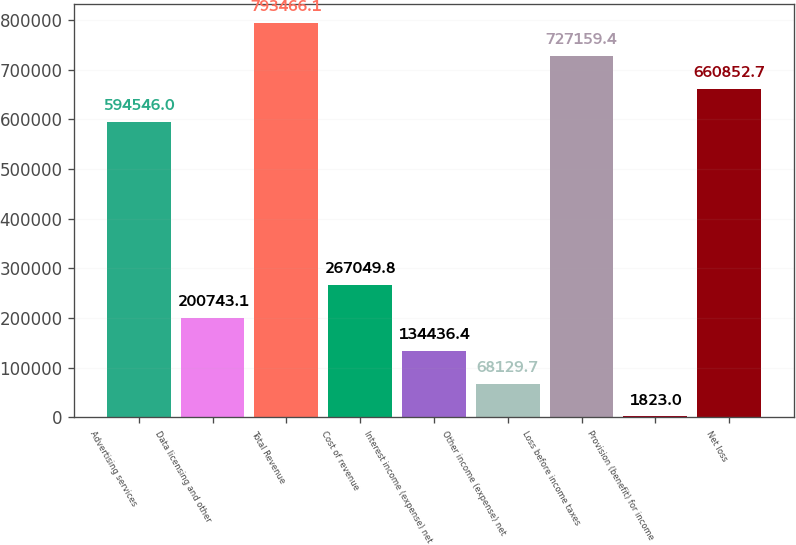Convert chart. <chart><loc_0><loc_0><loc_500><loc_500><bar_chart><fcel>Advertising services<fcel>Data licensing and other<fcel>Total Revenue<fcel>Cost of revenue<fcel>Interest income (expense) net<fcel>Other income (expense) net<fcel>Loss before income taxes<fcel>Provision (benefit) for income<fcel>Net loss<nl><fcel>594546<fcel>200743<fcel>793466<fcel>267050<fcel>134436<fcel>68129.7<fcel>727159<fcel>1823<fcel>660853<nl></chart> 